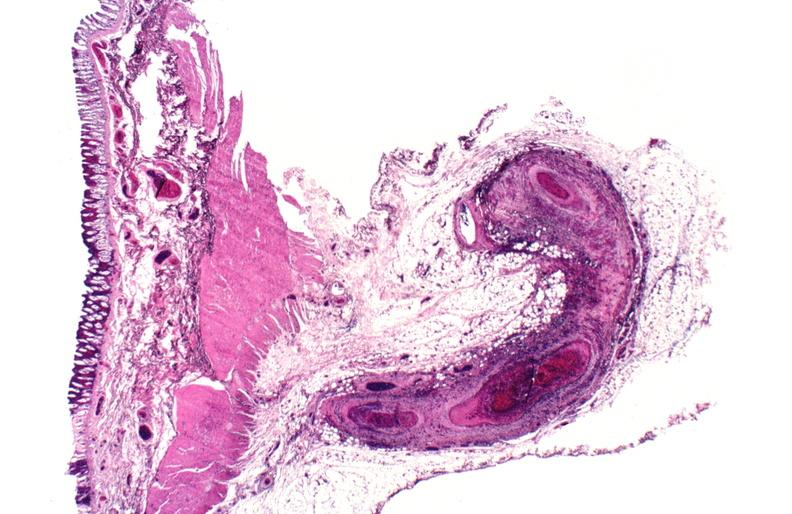s vasculature present?
Answer the question using a single word or phrase. Yes 